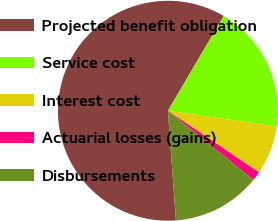<chart> <loc_0><loc_0><loc_500><loc_500><pie_chart><fcel>Projected benefit obligation<fcel>Service cost<fcel>Interest cost<fcel>Actuarial losses (gains)<fcel>Disbursements<nl><fcel>59.63%<fcel>18.83%<fcel>7.18%<fcel>1.35%<fcel>13.01%<nl></chart> 